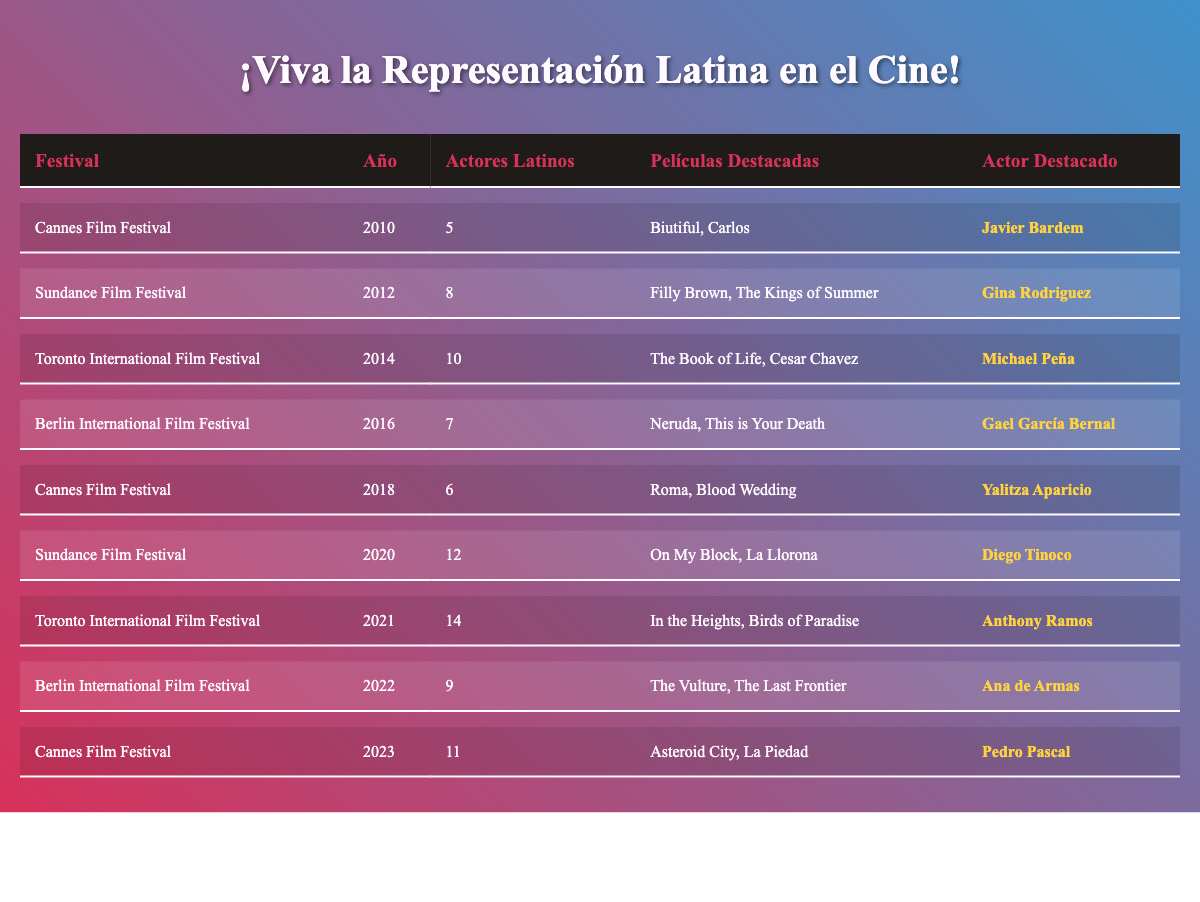What is the total number of Latino actors represented at the Toronto International Film Festival from 2010 to 2023? The data shows that the number of Latino actors represented at the Toronto International Film Festival in different years are: 0 for 2010, 0 for 2011, 10 for 2014, 14 for 2021. Adding these numbers gives us 10 + 14 = 24. Therefore, a total of 24 Latino actors were represented at the festival during this time frame.
Answer: 24 Which actor was highlighted at the Cannes Film Festival in 2023? Referring to the table, the highlighted actor at the Cannes Film Festival in 2023 is listed as Pedro Pascal.
Answer: Pedro Pascal Did the representation of Latino actors at Sundance Film Festival increase from 2012 to 2020? In 2012, there were 8 Latino actors represented. By 2020, this number increased to 12. Since 12 is greater than 8, this means that the representation did indeed increase during that period.
Answer: Yes What is the average number of Latino actors represented at the Berlin International Film Festival from 2016 to 2022? The number of Latino actors represented at the Berlin International Film Festival from 2016 to 2022 are: 7 in 2016, 9 in 2022. To find the average, we first add these together (7 + 9 = 16) and then divide by the number of years (16/2 = 8). The average number of Latino actors represented is therefore 8.
Answer: 8 How many notable films were listed for the Toronto International Film Festival in 2021? The table indicates that in 2021, the notable films listed for the Toronto International Film Festival were "In the Heights" and "Birds of Paradise." Therefore, there are 2 notable films for that year.
Answer: 2 Which festival had the highest representation of Latino actors in 2021? According to the data, the Toronto International Film Festival had 14 Latino actors represented in 2021, which is higher than any other festival listed for that year.
Answer: Toronto International Film Festival Was Gael García Bernal the highlighted actor at the Berlin International Film Festival in 2016? The data clearly states that Gael García Bernal was the highlighted actor at the Berlin International Film Festival in 2016, confirming this fact.
Answer: Yes What is the difference in the number of Latino actors represented at the Sundance Film Festival between 2012 and 2020? The representation in 2012 was 8 Latino actors and in 2020 it was 12 Latino actors. To find the difference, we subtract 8 from 12, which results in 4. Thus, the difference in representation is 4.
Answer: 4 In what year did Yalitza Aparicio stand out at the Cannes Film Festival? The table shows that Yalitza Aparicio was the highlighted actor at the Cannes Film Festival specifically in the year 2018.
Answer: 2018 